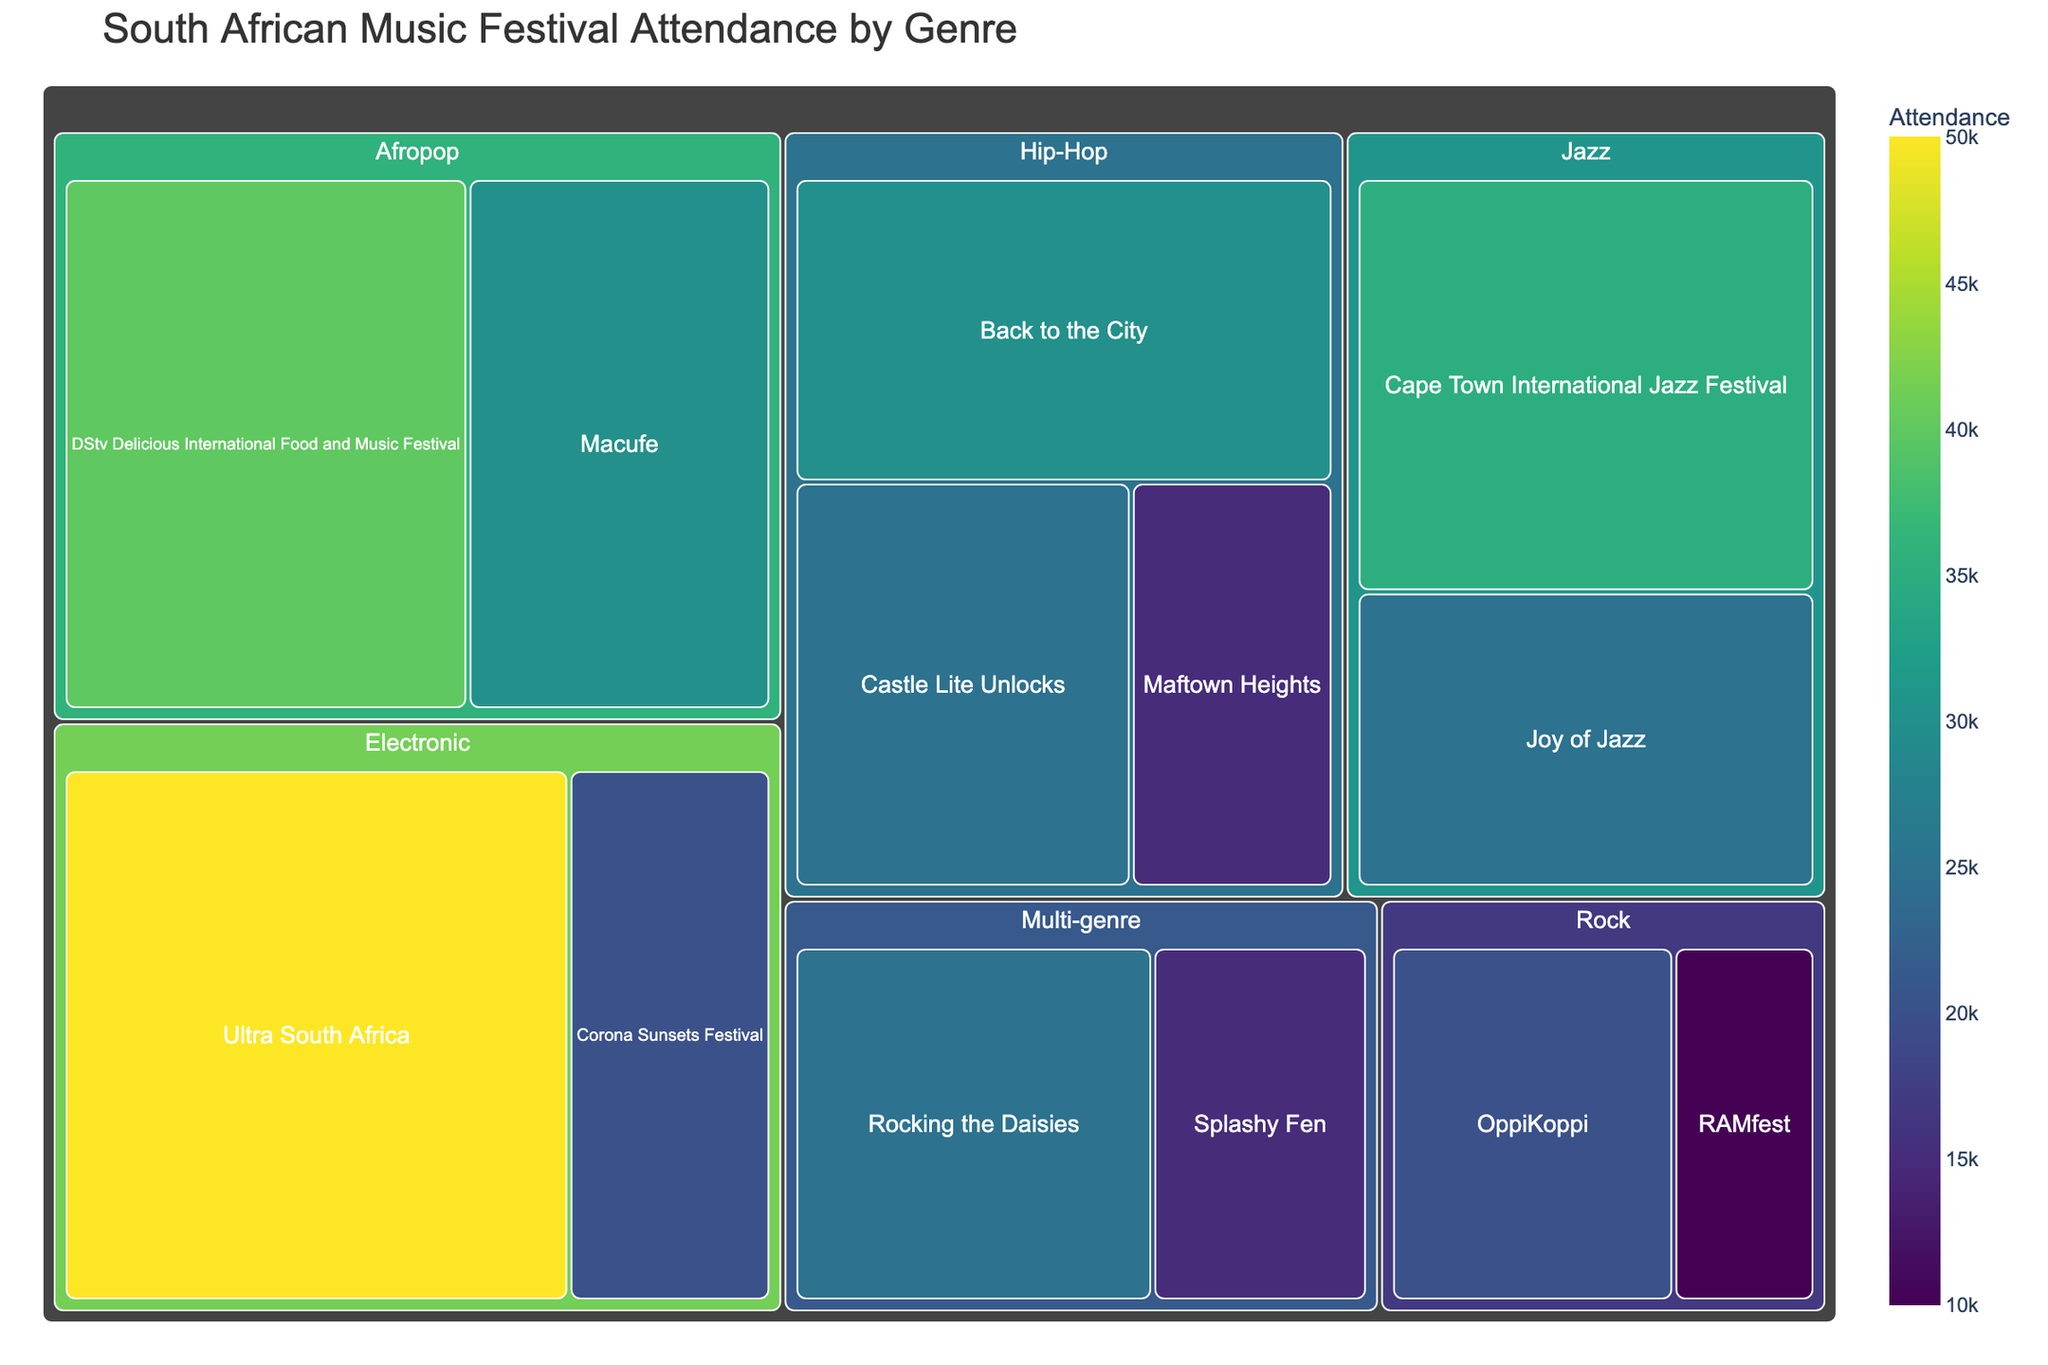Which genre has the highest overall attendance? First, identify the attendance for each festival within each genre and sum them up. The genre with the highest total attendance is Electronic, with Ultra South Africa (50,000) and Corona Sunsets Festival (20,000) summing to 70,000.
Answer: Electronic Which festival has the largest attendance within the Hip-Hop genre? Look at the attendance of each Hip-Hop festival: Back to the City (30,000), Castle Lite Unlocks (25,000), Maftown Heights (15,000). The largest attendance is Back to the City.
Answer: Back to the City What is the total attendance for the Jazz genre? Add the attendance of the Jazz festivals: Cape Town International Jazz Festival (35,000) and Joy of Jazz (25,000). The total is 35,000 + 25,000 = 60,000.
Answer: 60,000 Which genre has the smallest festival in terms of attendance? Identify the festivals with the smallest attendance within each genre: Hip-Hop (Maftown Heights, 15,000), Electronic (Corona Sunsets Festival, 20,000), Rock (RAMfest, 10,000), Jazz (Joy of Jazz, 25,000), Afropop (Macufe, 30,000), Multi-genre (Splashy Fen, 15,000). The smallest is RAMfest with 10,000.
Answer: Rock What is the average attendance for festivals in the Afropop genre? Calculate the sum of attendance for Afropop festivals: DStv Delicious International Food and Music Festival (40,000) and Macufe (30,000). The total is 70,000. There are 2 festivals, so the average is 70,000 ÷ 2 = 35,000.
Answer: 35,000 Which festival has the lowest overall attendance? Check the attendance of each festival listed: the lowest is RAMfest with 10,000.
Answer: RAMfest Compare the total attendance of Rock and Multi-genre festivals. Which is greater? Calculate the sum of attendance for Rock: OppiKoppi (20,000) + RAMfest (10,000) = 30,000. For Multi-genre: Rocking the Daisies (25,000) + Splashy Fen (15,000) = 40,000. Multi-genre has a greater total attendance of 40,000 compared to Rock's 30,000.
Answer: Multi-genre How many festivals have an attendance of 25,000? Identify the festivals with 25,000 attendance: Castle Lite Unlocks (Hip-Hop), Joy of Jazz (Jazz), and Rocking the Daisies (Multi-genre). There are 3 festivals with this attendance.
Answer: 3 Which festival has the second highest attendance in the entire treemap? The highest attendance is Ultra South Africa (50,000). The next highest is Cape Town International Jazz Festival with 35,000.
Answer: Cape Town International Jazz Festival 